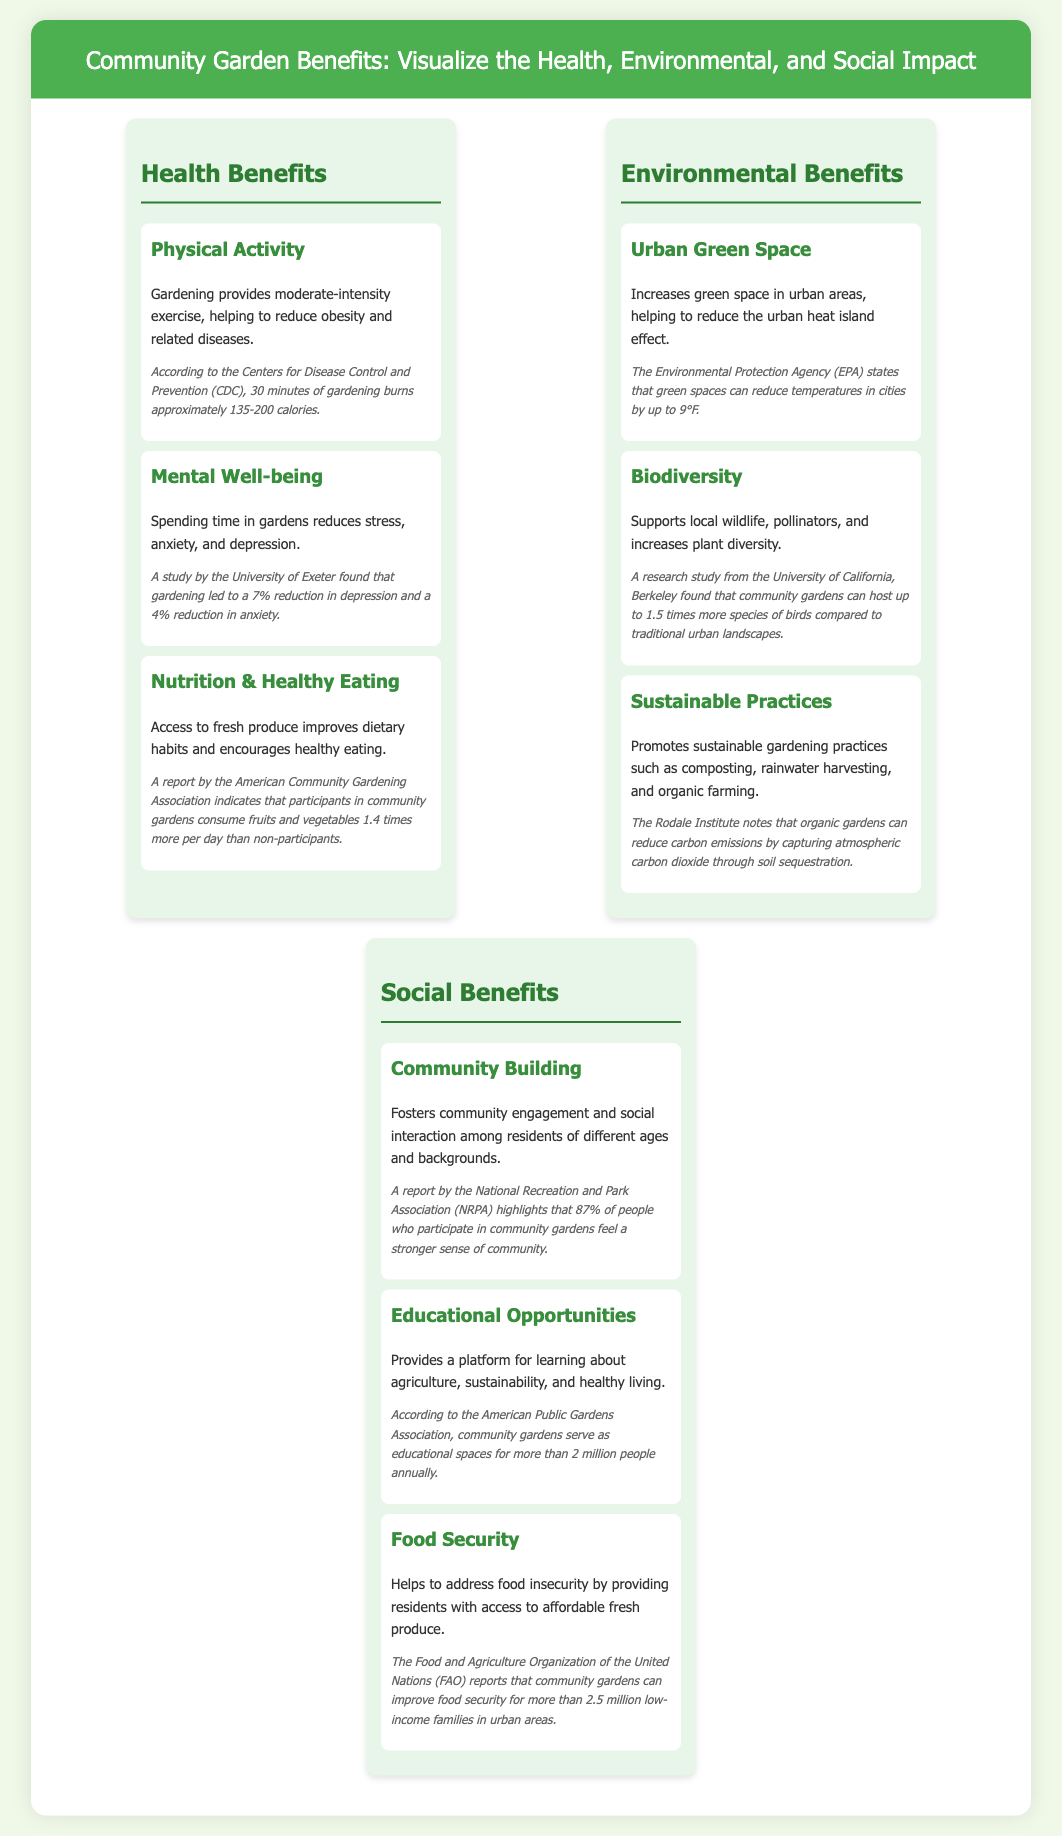What is one physical health benefit of gardening? The document states that gardening provides moderate-intensity exercise, helping to reduce obesity and related diseases.
Answer: Moderate-intensity exercise What percentage of community garden participants feel a stronger sense of community? According to the report by the National Recreation and Park Association, 87% of participants feel a stronger sense of community.
Answer: 87% What environmental benefit can urban green spaces provide in terms of temperature reduction? The Environmental Protection Agency states that green spaces can reduce temperatures in cities by up to 9°F.
Answer: 9°F How many species of birds can community gardens host compared to traditional urban landscapes? A research study found that community gardens can host up to 1.5 times more species of birds.
Answer: 1.5 times What is the annual number of people that benefit from educational opportunities in community gardens? According to the American Public Gardens Association, community gardens serve as educational spaces for more than 2 million people annually.
Answer: 2 million What type of sustainable practices are promoted in community gardens? The document mentions that sustainable gardening practices such as composting, rainwater harvesting, and organic farming are promoted.
Answer: Composting, rainwater harvesting, organic farming How much can community gardens improve food security for low-income families? The Food and Agriculture Organization reports that community gardens can improve food security for more than 2.5 million low-income families.
Answer: 2.5 million What is the primary theme of this infographic? The primary theme focuses on the health, environmental, and social impact of community gardens as illustrated throughout the document.
Answer: Community garden benefits 